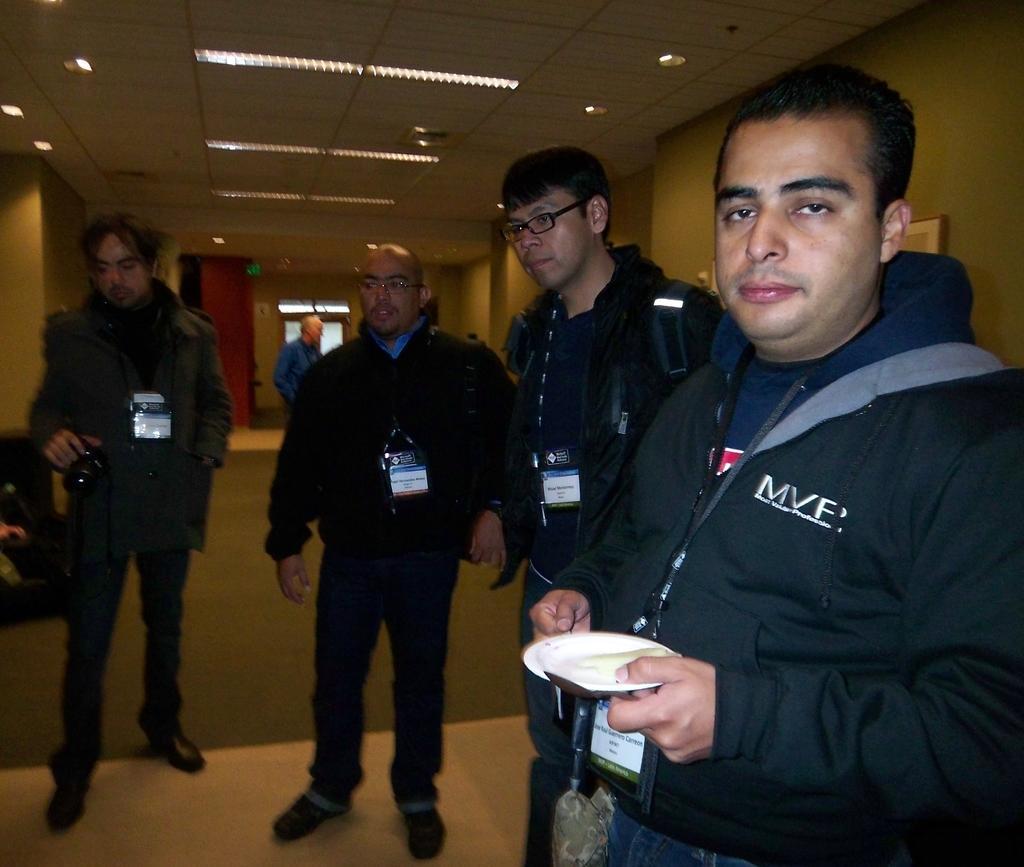In one or two sentences, can you explain what this image depicts? In this picture I can see the people standing on the surface. I can see a person holding the camera on the left side. I can see light arrangements on the roof. 